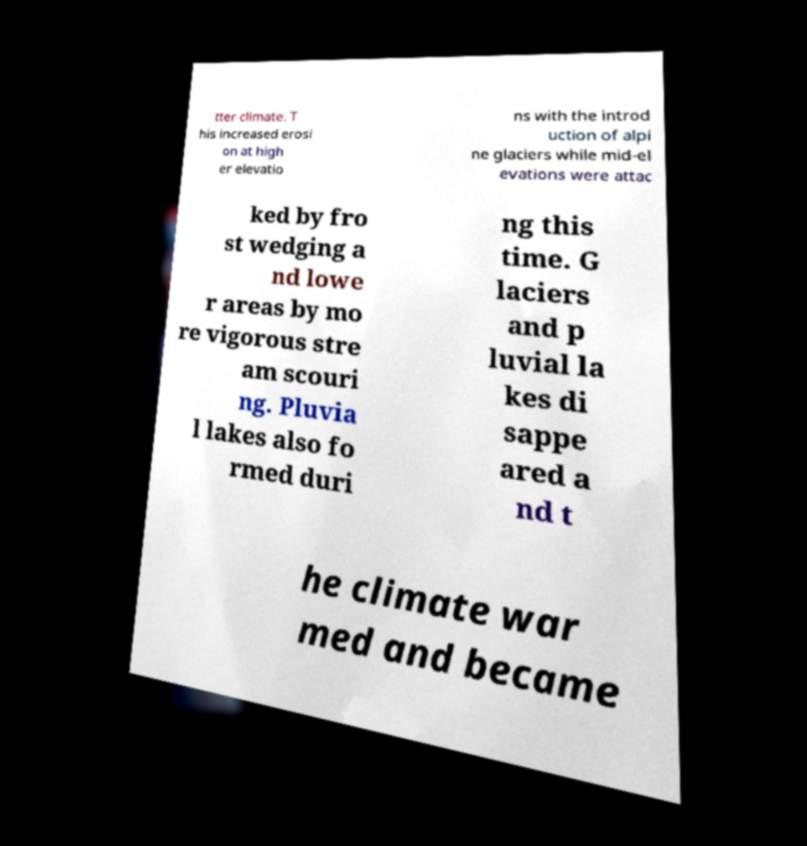Could you extract and type out the text from this image? tter climate. T his increased erosi on at high er elevatio ns with the introd uction of alpi ne glaciers while mid-el evations were attac ked by fro st wedging a nd lowe r areas by mo re vigorous stre am scouri ng. Pluvia l lakes also fo rmed duri ng this time. G laciers and p luvial la kes di sappe ared a nd t he climate war med and became 